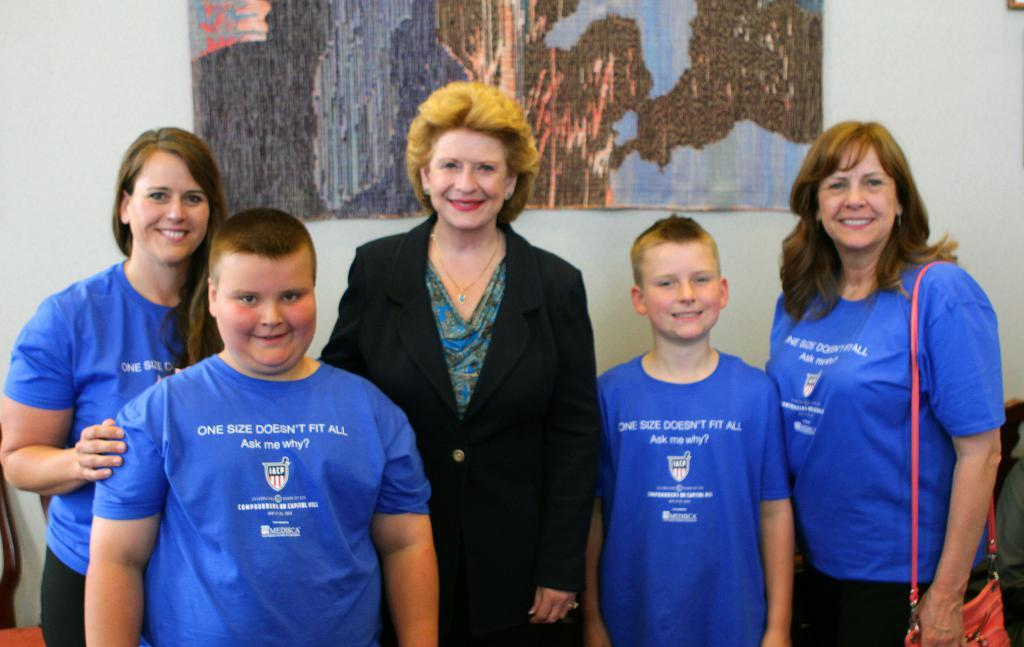<image>
Share a concise interpretation of the image provided. A group of people, four of which are wearing blue shirts saying "One size doesn't fit all" 